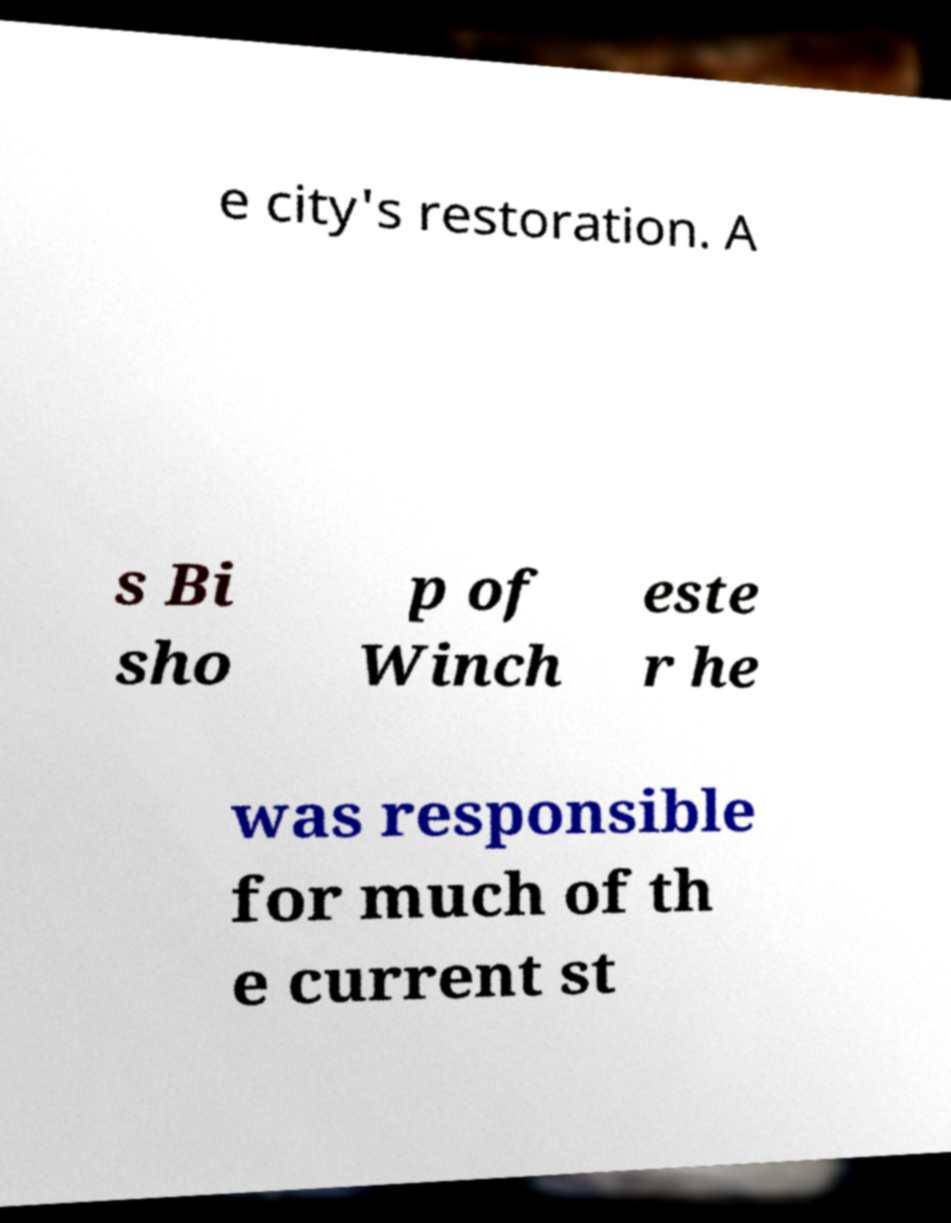Can you read and provide the text displayed in the image?This photo seems to have some interesting text. Can you extract and type it out for me? e city's restoration. A s Bi sho p of Winch este r he was responsible for much of th e current st 